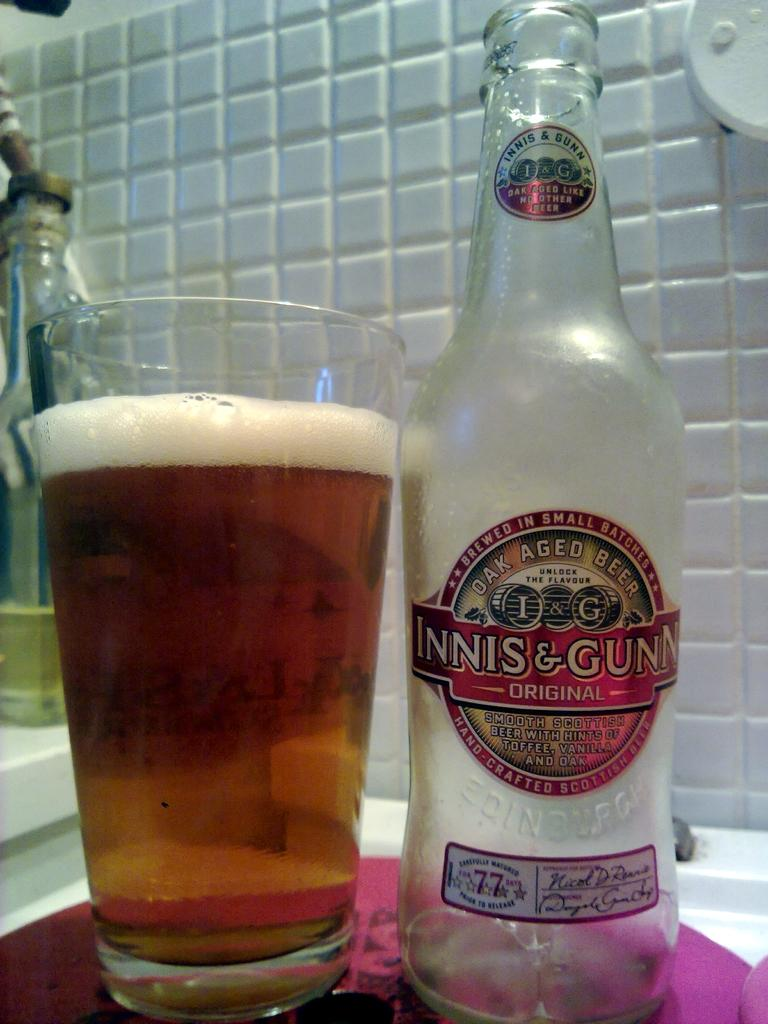<image>
Provide a brief description of the given image. an empty bottle of oak aged beer by innis & gunns 